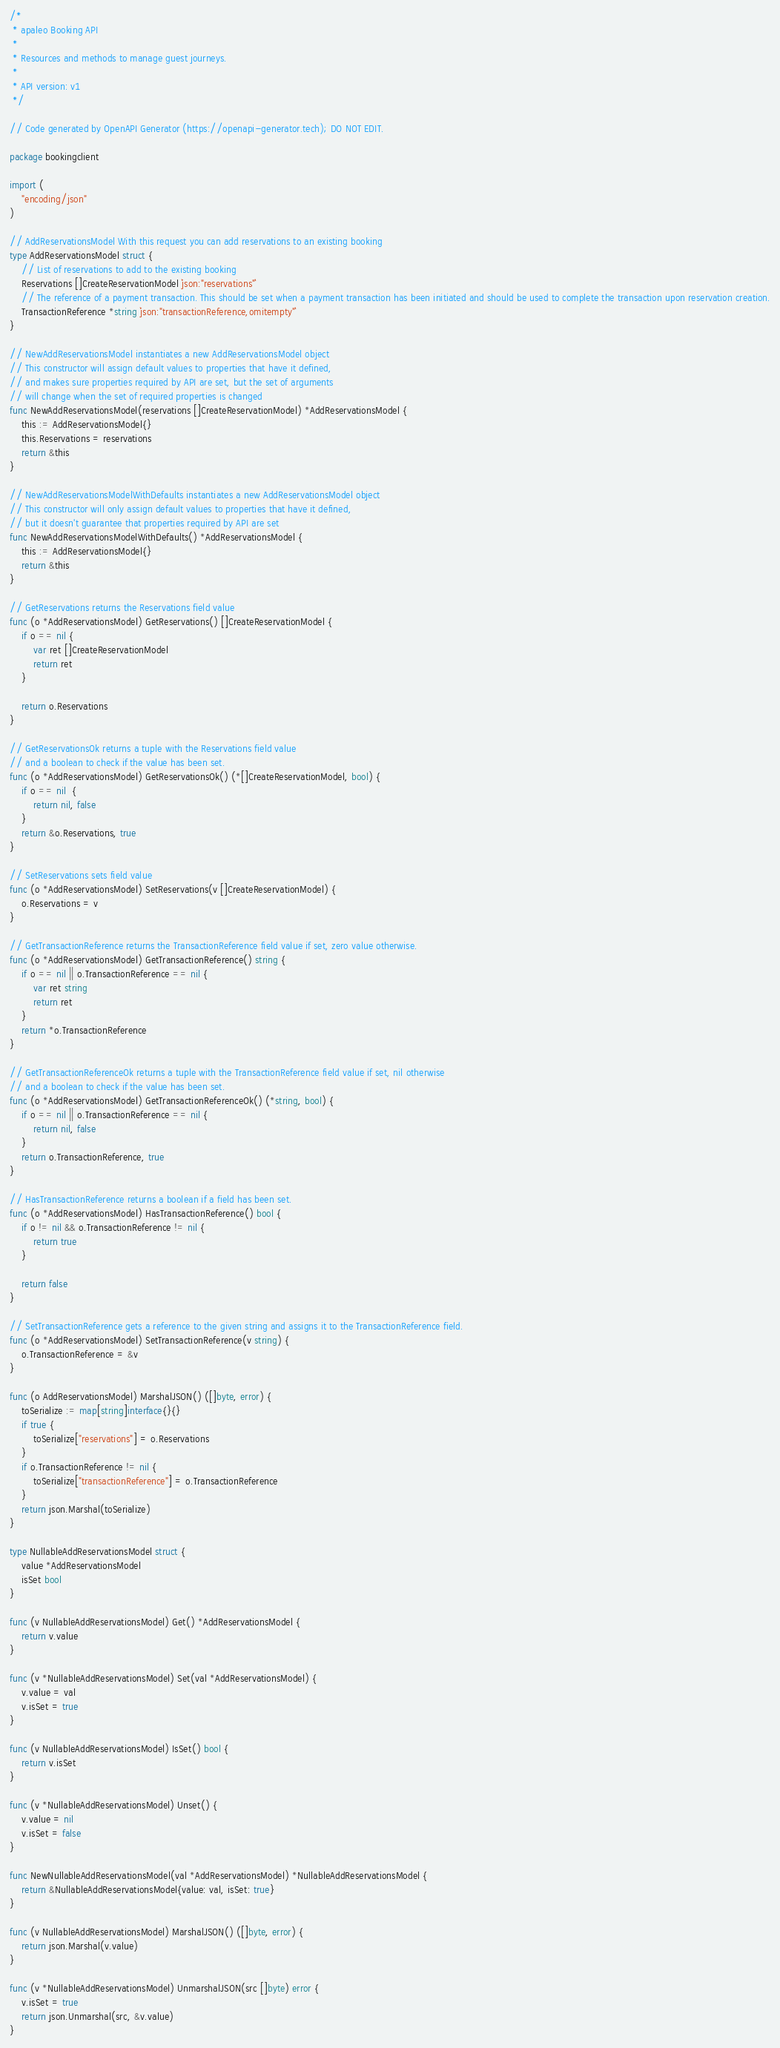Convert code to text. <code><loc_0><loc_0><loc_500><loc_500><_Go_>/*
 * apaleo Booking API
 *
 * Resources and methods to manage guest journeys.
 *
 * API version: v1
 */

// Code generated by OpenAPI Generator (https://openapi-generator.tech); DO NOT EDIT.

package bookingclient

import (
	"encoding/json"
)

// AddReservationsModel With this request you can add reservations to an existing booking
type AddReservationsModel struct {
	// List of reservations to add to the existing booking
	Reservations []CreateReservationModel `json:"reservations"`
	// The reference of a payment transaction. This should be set when a payment transaction has been initiated and should be used to complete the transaction upon reservation creation.
	TransactionReference *string `json:"transactionReference,omitempty"`
}

// NewAddReservationsModel instantiates a new AddReservationsModel object
// This constructor will assign default values to properties that have it defined,
// and makes sure properties required by API are set, but the set of arguments
// will change when the set of required properties is changed
func NewAddReservationsModel(reservations []CreateReservationModel) *AddReservationsModel {
	this := AddReservationsModel{}
	this.Reservations = reservations
	return &this
}

// NewAddReservationsModelWithDefaults instantiates a new AddReservationsModel object
// This constructor will only assign default values to properties that have it defined,
// but it doesn't guarantee that properties required by API are set
func NewAddReservationsModelWithDefaults() *AddReservationsModel {
	this := AddReservationsModel{}
	return &this
}

// GetReservations returns the Reservations field value
func (o *AddReservationsModel) GetReservations() []CreateReservationModel {
	if o == nil {
		var ret []CreateReservationModel
		return ret
	}

	return o.Reservations
}

// GetReservationsOk returns a tuple with the Reservations field value
// and a boolean to check if the value has been set.
func (o *AddReservationsModel) GetReservationsOk() (*[]CreateReservationModel, bool) {
	if o == nil  {
		return nil, false
	}
	return &o.Reservations, true
}

// SetReservations sets field value
func (o *AddReservationsModel) SetReservations(v []CreateReservationModel) {
	o.Reservations = v
}

// GetTransactionReference returns the TransactionReference field value if set, zero value otherwise.
func (o *AddReservationsModel) GetTransactionReference() string {
	if o == nil || o.TransactionReference == nil {
		var ret string
		return ret
	}
	return *o.TransactionReference
}

// GetTransactionReferenceOk returns a tuple with the TransactionReference field value if set, nil otherwise
// and a boolean to check if the value has been set.
func (o *AddReservationsModel) GetTransactionReferenceOk() (*string, bool) {
	if o == nil || o.TransactionReference == nil {
		return nil, false
	}
	return o.TransactionReference, true
}

// HasTransactionReference returns a boolean if a field has been set.
func (o *AddReservationsModel) HasTransactionReference() bool {
	if o != nil && o.TransactionReference != nil {
		return true
	}

	return false
}

// SetTransactionReference gets a reference to the given string and assigns it to the TransactionReference field.
func (o *AddReservationsModel) SetTransactionReference(v string) {
	o.TransactionReference = &v
}

func (o AddReservationsModel) MarshalJSON() ([]byte, error) {
	toSerialize := map[string]interface{}{}
	if true {
		toSerialize["reservations"] = o.Reservations
	}
	if o.TransactionReference != nil {
		toSerialize["transactionReference"] = o.TransactionReference
	}
	return json.Marshal(toSerialize)
}

type NullableAddReservationsModel struct {
	value *AddReservationsModel
	isSet bool
}

func (v NullableAddReservationsModel) Get() *AddReservationsModel {
	return v.value
}

func (v *NullableAddReservationsModel) Set(val *AddReservationsModel) {
	v.value = val
	v.isSet = true
}

func (v NullableAddReservationsModel) IsSet() bool {
	return v.isSet
}

func (v *NullableAddReservationsModel) Unset() {
	v.value = nil
	v.isSet = false
}

func NewNullableAddReservationsModel(val *AddReservationsModel) *NullableAddReservationsModel {
	return &NullableAddReservationsModel{value: val, isSet: true}
}

func (v NullableAddReservationsModel) MarshalJSON() ([]byte, error) {
	return json.Marshal(v.value)
}

func (v *NullableAddReservationsModel) UnmarshalJSON(src []byte) error {
	v.isSet = true
	return json.Unmarshal(src, &v.value)
}


</code> 